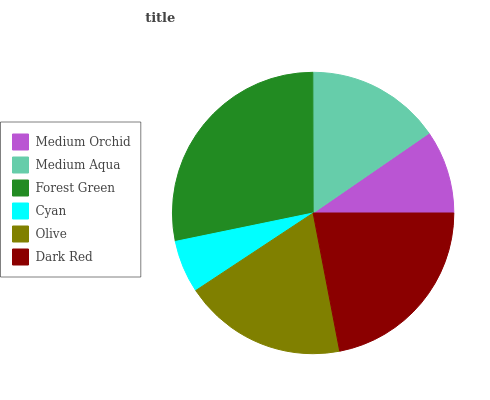Is Cyan the minimum?
Answer yes or no. Yes. Is Forest Green the maximum?
Answer yes or no. Yes. Is Medium Aqua the minimum?
Answer yes or no. No. Is Medium Aqua the maximum?
Answer yes or no. No. Is Medium Aqua greater than Medium Orchid?
Answer yes or no. Yes. Is Medium Orchid less than Medium Aqua?
Answer yes or no. Yes. Is Medium Orchid greater than Medium Aqua?
Answer yes or no. No. Is Medium Aqua less than Medium Orchid?
Answer yes or no. No. Is Olive the high median?
Answer yes or no. Yes. Is Medium Aqua the low median?
Answer yes or no. Yes. Is Forest Green the high median?
Answer yes or no. No. Is Forest Green the low median?
Answer yes or no. No. 